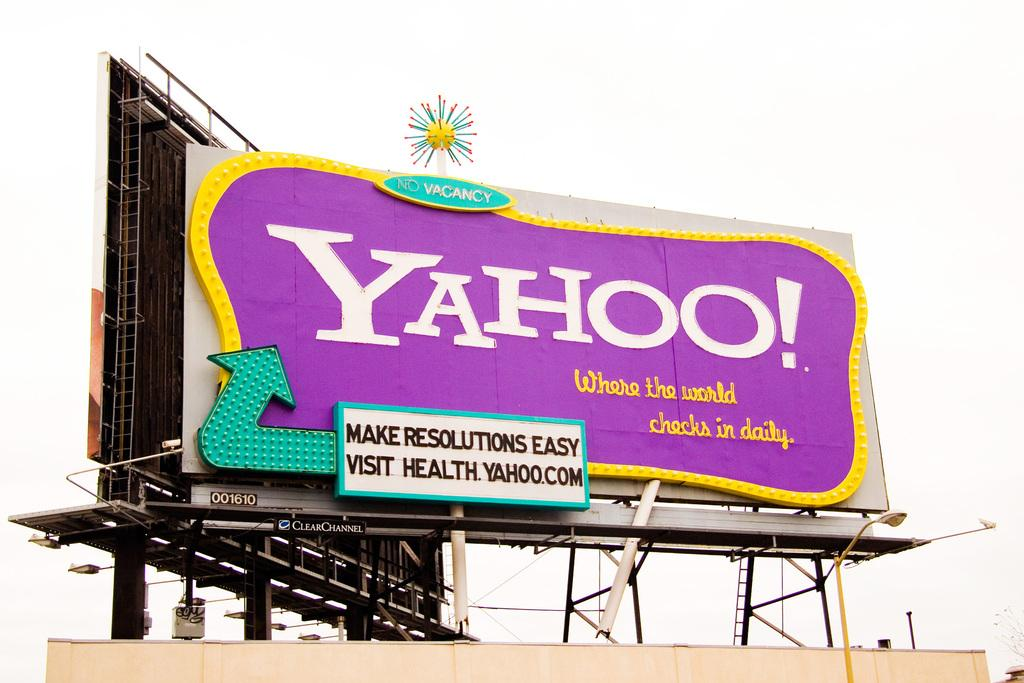<image>
Render a clear and concise summary of the photo. Purple Yahoo billboard outdoors on a cloudy day. 